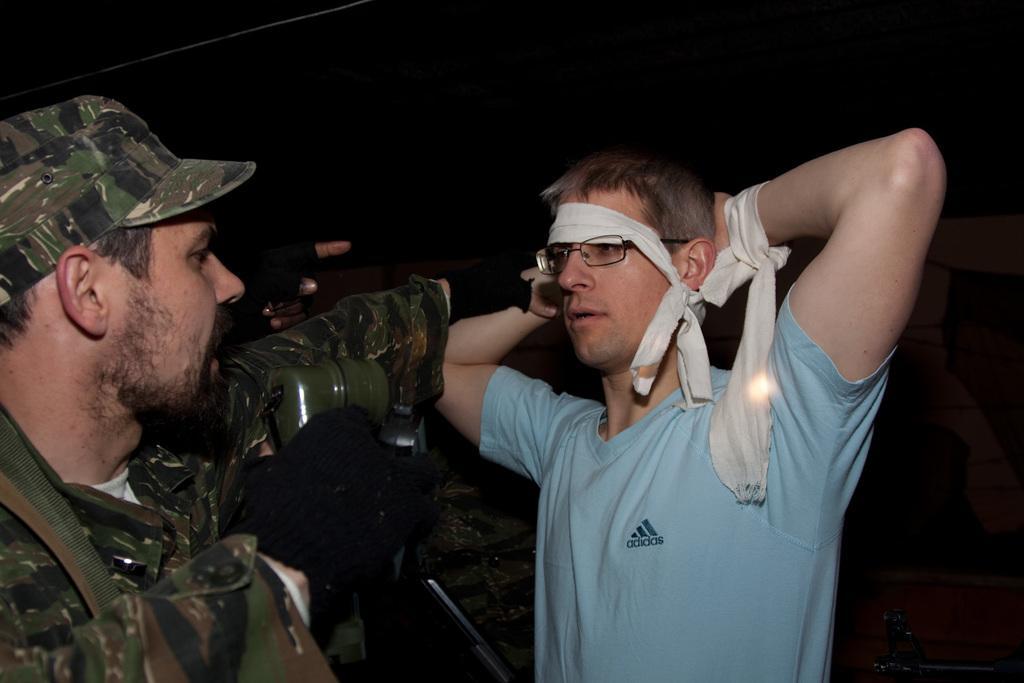Could you give a brief overview of what you see in this image? There are two men standing in the foreground area of the image and the background is black. 